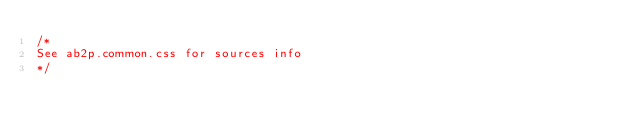Convert code to text. <code><loc_0><loc_0><loc_500><loc_500><_CSS_>/*
See ab2p.common.css for sources info
*/</code> 